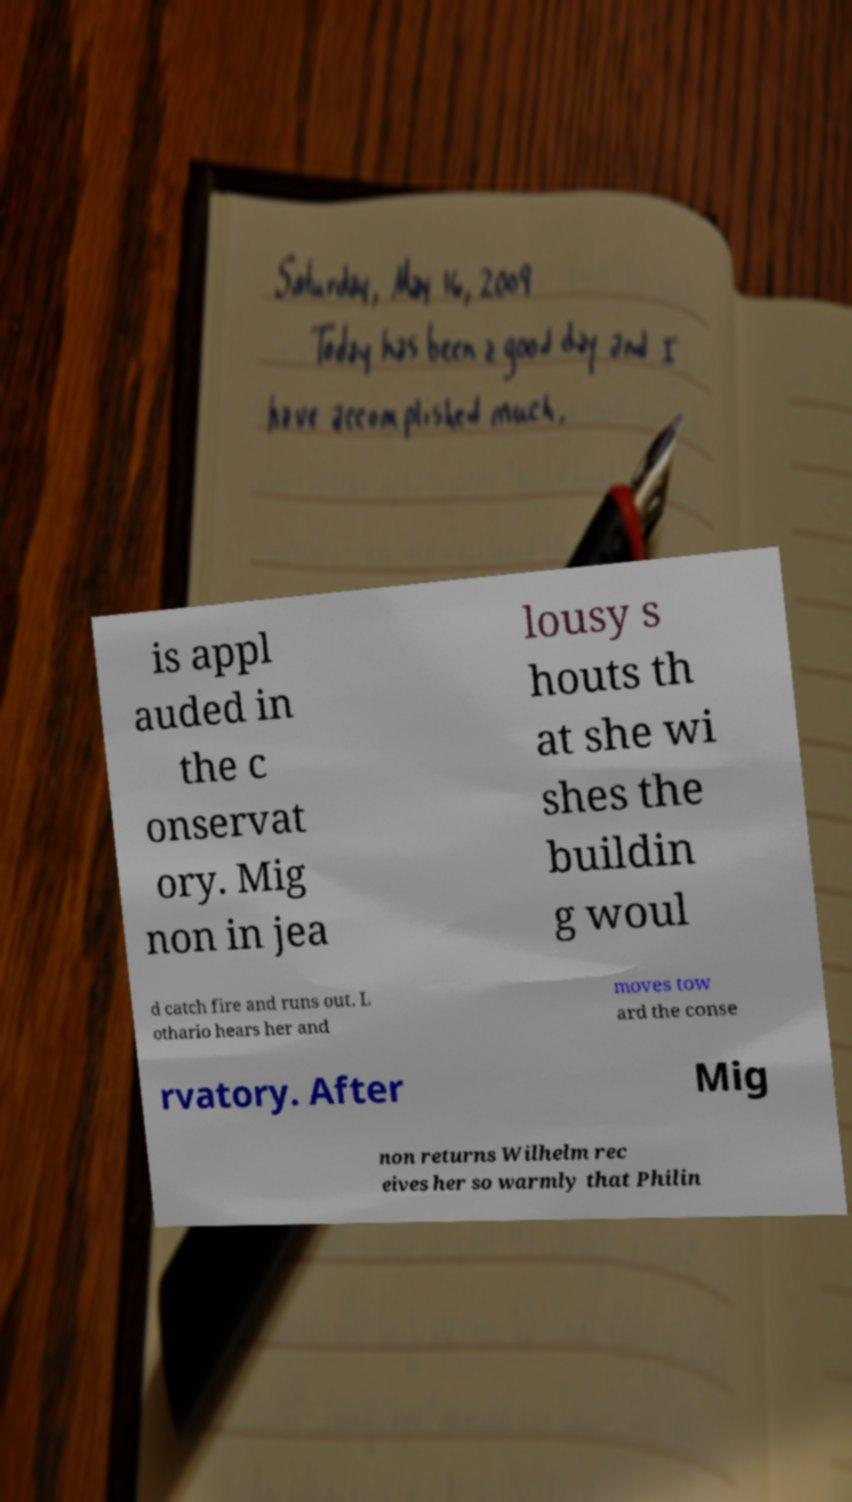Could you extract and type out the text from this image? is appl auded in the c onservat ory. Mig non in jea lousy s houts th at she wi shes the buildin g woul d catch fire and runs out. L othario hears her and moves tow ard the conse rvatory. After Mig non returns Wilhelm rec eives her so warmly that Philin 